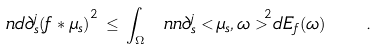<formula> <loc_0><loc_0><loc_500><loc_500>\ n d { \partial _ { s } ^ { j } ( f * \mu _ { s } ) } ^ { 2 } \, \leq \, \int _ { \Omega } \ n n { \partial _ { s } ^ { j } < \mu _ { s } , \omega > } ^ { 2 } d E _ { f } ( \omega ) \quad .</formula> 